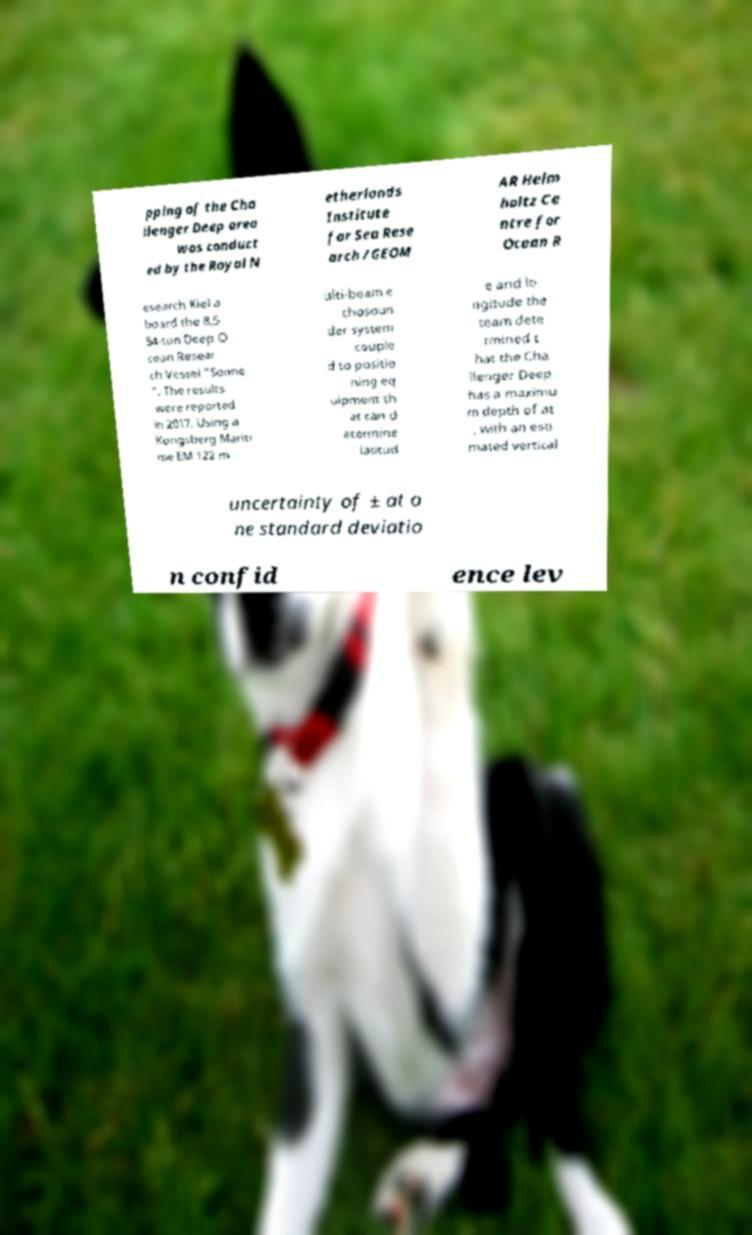Could you extract and type out the text from this image? pping of the Cha llenger Deep area was conduct ed by the Royal N etherlands Institute for Sea Rese arch /GEOM AR Helm holtz Ce ntre for Ocean R esearch Kiel a board the 8,5 54-ton Deep O cean Resear ch Vessel "Sonne ". The results were reported in 2017. Using a Kongsberg Mariti me EM 122 m ulti-beam e chosoun der system couple d to positio ning eq uipment th at can d etermine latitud e and lo ngitude the team dete rmined t hat the Cha llenger Deep has a maximu m depth of at , with an esti mated vertical uncertainty of ± at o ne standard deviatio n confid ence lev 